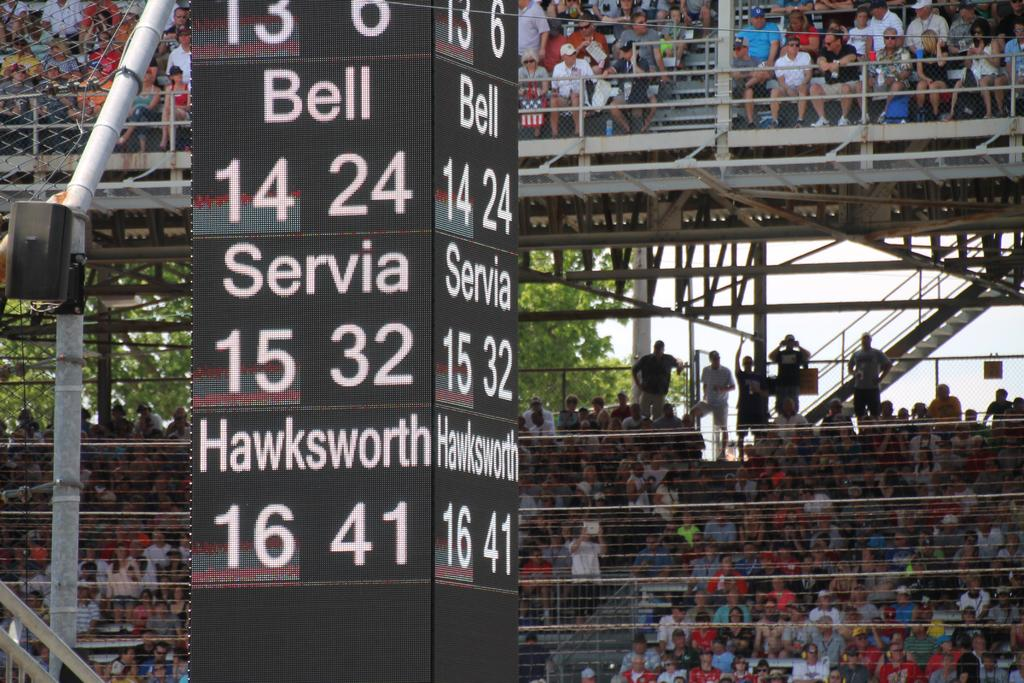<image>
Write a terse but informative summary of the picture. Team scores such as Bell, Servia, and Hawksworth are shown on a tall, black, square structure, in front of the stands. 